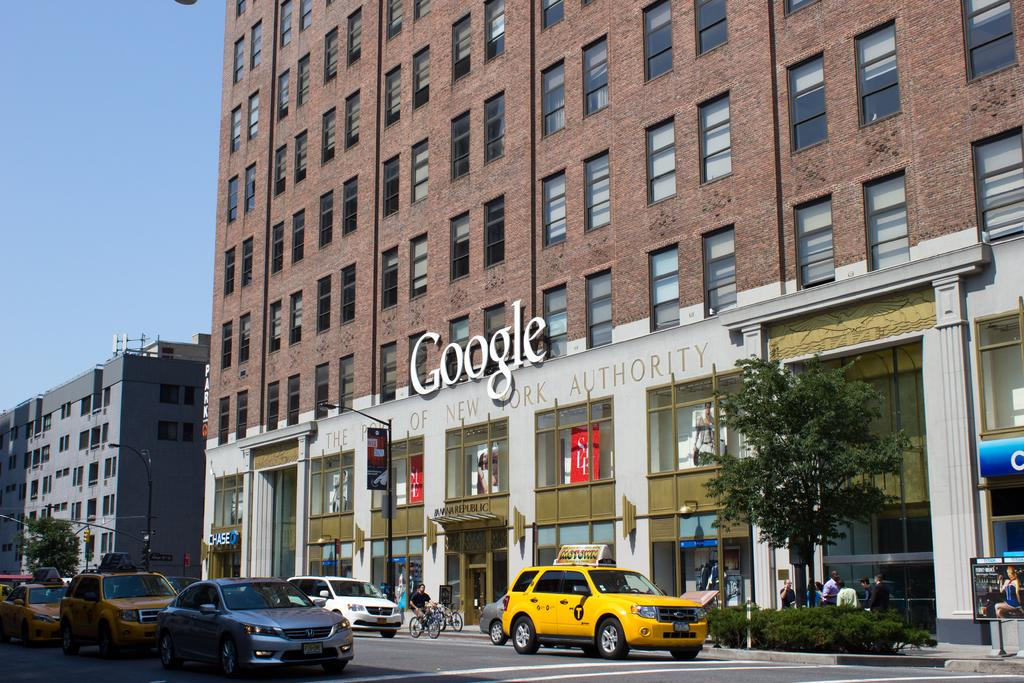<image>
Share a concise interpretation of the image provided. The Port of New York Authority building is also sponsored by Google. 